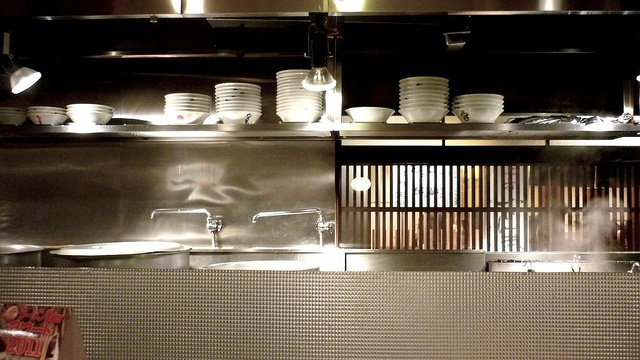Describe the objects in this image and their specific colors. I can see bowl in black, ivory, darkgray, and gray tones, sink in black, white, gray, and darkgray tones, sink in black, white, darkgray, and lightgray tones, sink in black, white, darkgray, lightgray, and gray tones, and bowl in black, gray, darkgray, and lightgray tones in this image. 